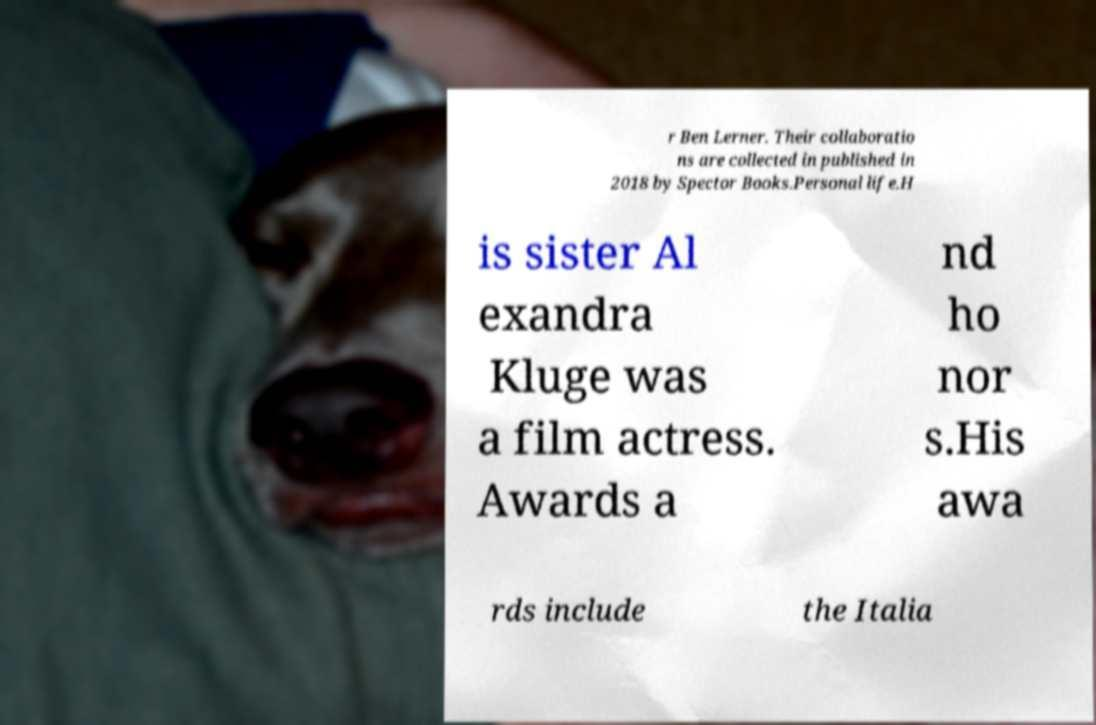Could you assist in decoding the text presented in this image and type it out clearly? r Ben Lerner. Their collaboratio ns are collected in published in 2018 by Spector Books.Personal life.H is sister Al exandra Kluge was a film actress. Awards a nd ho nor s.His awa rds include the Italia 